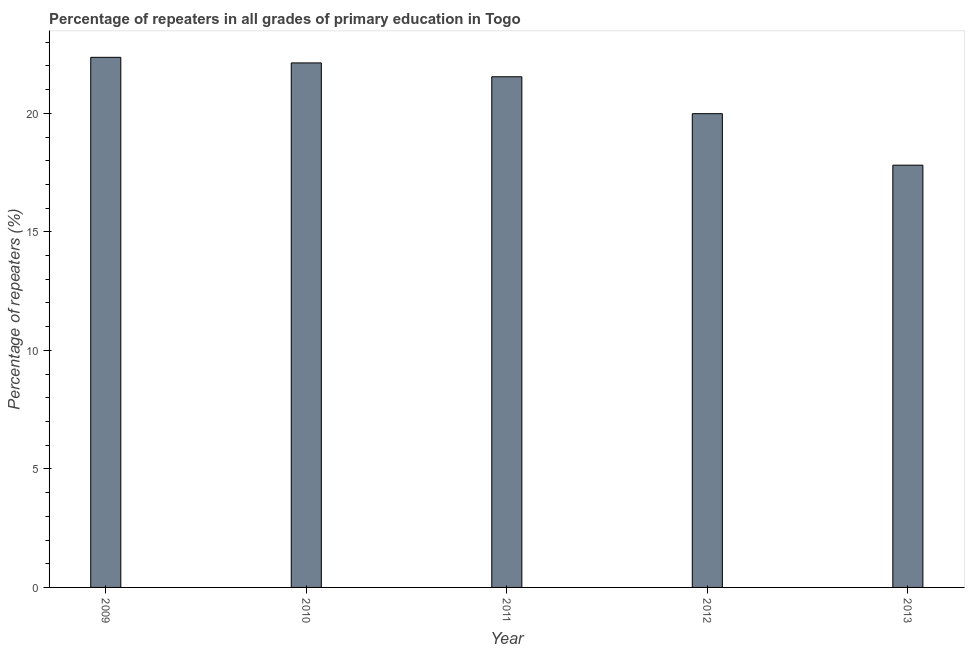What is the title of the graph?
Provide a short and direct response. Percentage of repeaters in all grades of primary education in Togo. What is the label or title of the Y-axis?
Offer a terse response. Percentage of repeaters (%). What is the percentage of repeaters in primary education in 2009?
Offer a terse response. 22.36. Across all years, what is the maximum percentage of repeaters in primary education?
Keep it short and to the point. 22.36. Across all years, what is the minimum percentage of repeaters in primary education?
Offer a terse response. 17.81. What is the sum of the percentage of repeaters in primary education?
Provide a short and direct response. 103.84. What is the difference between the percentage of repeaters in primary education in 2009 and 2011?
Your answer should be very brief. 0.82. What is the average percentage of repeaters in primary education per year?
Your response must be concise. 20.77. What is the median percentage of repeaters in primary education?
Your response must be concise. 21.54. Do a majority of the years between 2013 and 2012 (inclusive) have percentage of repeaters in primary education greater than 14 %?
Your response must be concise. No. What is the ratio of the percentage of repeaters in primary education in 2009 to that in 2010?
Provide a short and direct response. 1.01. Is the percentage of repeaters in primary education in 2012 less than that in 2013?
Give a very brief answer. No. What is the difference between the highest and the second highest percentage of repeaters in primary education?
Give a very brief answer. 0.24. What is the difference between the highest and the lowest percentage of repeaters in primary education?
Your response must be concise. 4.55. How many years are there in the graph?
Keep it short and to the point. 5. What is the difference between two consecutive major ticks on the Y-axis?
Offer a terse response. 5. What is the Percentage of repeaters (%) in 2009?
Offer a very short reply. 22.36. What is the Percentage of repeaters (%) of 2010?
Offer a terse response. 22.13. What is the Percentage of repeaters (%) of 2011?
Your response must be concise. 21.54. What is the Percentage of repeaters (%) of 2012?
Your response must be concise. 19.99. What is the Percentage of repeaters (%) in 2013?
Your answer should be compact. 17.81. What is the difference between the Percentage of repeaters (%) in 2009 and 2010?
Your answer should be compact. 0.24. What is the difference between the Percentage of repeaters (%) in 2009 and 2011?
Your answer should be compact. 0.82. What is the difference between the Percentage of repeaters (%) in 2009 and 2012?
Ensure brevity in your answer.  2.38. What is the difference between the Percentage of repeaters (%) in 2009 and 2013?
Provide a succinct answer. 4.55. What is the difference between the Percentage of repeaters (%) in 2010 and 2011?
Offer a terse response. 0.58. What is the difference between the Percentage of repeaters (%) in 2010 and 2012?
Your response must be concise. 2.14. What is the difference between the Percentage of repeaters (%) in 2010 and 2013?
Offer a terse response. 4.31. What is the difference between the Percentage of repeaters (%) in 2011 and 2012?
Your answer should be very brief. 1.56. What is the difference between the Percentage of repeaters (%) in 2011 and 2013?
Offer a very short reply. 3.73. What is the difference between the Percentage of repeaters (%) in 2012 and 2013?
Offer a very short reply. 2.17. What is the ratio of the Percentage of repeaters (%) in 2009 to that in 2010?
Provide a succinct answer. 1.01. What is the ratio of the Percentage of repeaters (%) in 2009 to that in 2011?
Your answer should be compact. 1.04. What is the ratio of the Percentage of repeaters (%) in 2009 to that in 2012?
Offer a terse response. 1.12. What is the ratio of the Percentage of repeaters (%) in 2009 to that in 2013?
Provide a succinct answer. 1.25. What is the ratio of the Percentage of repeaters (%) in 2010 to that in 2011?
Your answer should be compact. 1.03. What is the ratio of the Percentage of repeaters (%) in 2010 to that in 2012?
Your answer should be compact. 1.11. What is the ratio of the Percentage of repeaters (%) in 2010 to that in 2013?
Make the answer very short. 1.24. What is the ratio of the Percentage of repeaters (%) in 2011 to that in 2012?
Offer a terse response. 1.08. What is the ratio of the Percentage of repeaters (%) in 2011 to that in 2013?
Offer a terse response. 1.21. What is the ratio of the Percentage of repeaters (%) in 2012 to that in 2013?
Offer a very short reply. 1.12. 